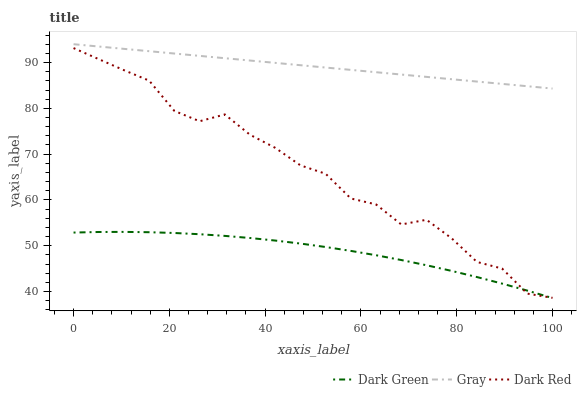Does Dark Red have the minimum area under the curve?
Answer yes or no. No. Does Dark Red have the maximum area under the curve?
Answer yes or no. No. Is Dark Green the smoothest?
Answer yes or no. No. Is Dark Green the roughest?
Answer yes or no. No. Does Dark Red have the lowest value?
Answer yes or no. No. Does Dark Red have the highest value?
Answer yes or no. No. Is Dark Red less than Gray?
Answer yes or no. Yes. Is Gray greater than Dark Red?
Answer yes or no. Yes. Does Dark Red intersect Gray?
Answer yes or no. No. 